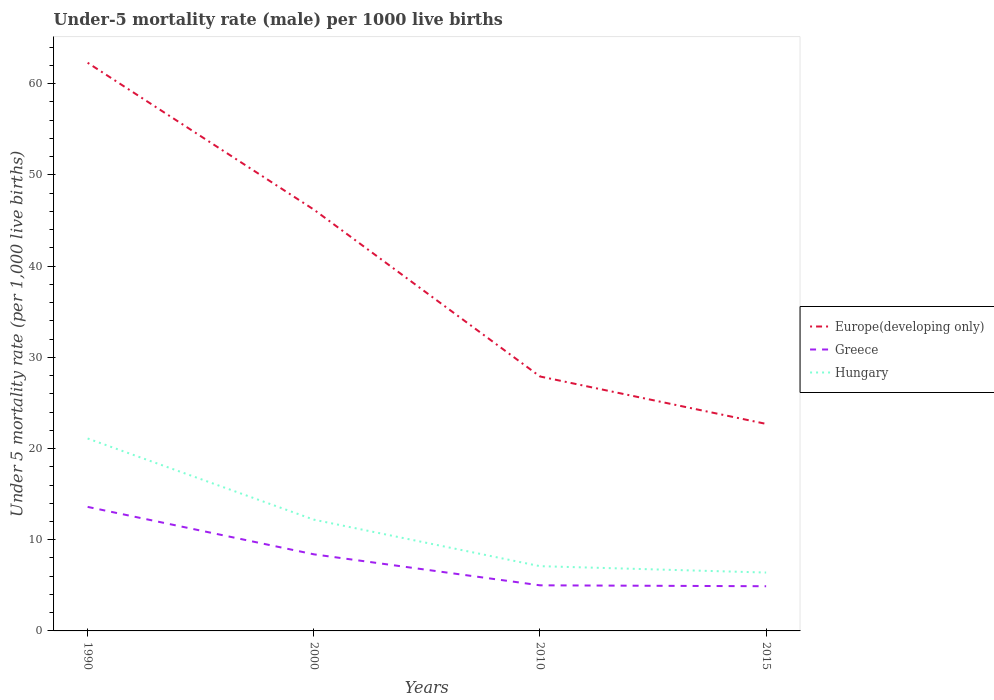Does the line corresponding to Europe(developing only) intersect with the line corresponding to Hungary?
Your answer should be very brief. No. Is the number of lines equal to the number of legend labels?
Offer a very short reply. Yes. Across all years, what is the maximum under-five mortality rate in Europe(developing only)?
Your response must be concise. 22.7. In which year was the under-five mortality rate in Europe(developing only) maximum?
Your answer should be compact. 2015. What is the total under-five mortality rate in Europe(developing only) in the graph?
Make the answer very short. 39.6. What is the difference between the highest and the second highest under-five mortality rate in Hungary?
Provide a succinct answer. 14.7. What is the difference between two consecutive major ticks on the Y-axis?
Offer a terse response. 10. Does the graph contain grids?
Offer a very short reply. No. Where does the legend appear in the graph?
Provide a succinct answer. Center right. How many legend labels are there?
Offer a terse response. 3. How are the legend labels stacked?
Offer a terse response. Vertical. What is the title of the graph?
Your response must be concise. Under-5 mortality rate (male) per 1000 live births. What is the label or title of the Y-axis?
Offer a very short reply. Under 5 mortality rate (per 1,0 live births). What is the Under 5 mortality rate (per 1,000 live births) of Europe(developing only) in 1990?
Ensure brevity in your answer.  62.3. What is the Under 5 mortality rate (per 1,000 live births) of Hungary in 1990?
Provide a succinct answer. 21.1. What is the Under 5 mortality rate (per 1,000 live births) in Europe(developing only) in 2000?
Offer a very short reply. 46.2. What is the Under 5 mortality rate (per 1,000 live births) in Europe(developing only) in 2010?
Offer a very short reply. 27.9. What is the Under 5 mortality rate (per 1,000 live births) of Europe(developing only) in 2015?
Your answer should be very brief. 22.7. What is the Under 5 mortality rate (per 1,000 live births) in Greece in 2015?
Provide a short and direct response. 4.9. Across all years, what is the maximum Under 5 mortality rate (per 1,000 live births) in Europe(developing only)?
Provide a succinct answer. 62.3. Across all years, what is the maximum Under 5 mortality rate (per 1,000 live births) of Hungary?
Provide a succinct answer. 21.1. Across all years, what is the minimum Under 5 mortality rate (per 1,000 live births) in Europe(developing only)?
Offer a terse response. 22.7. What is the total Under 5 mortality rate (per 1,000 live births) in Europe(developing only) in the graph?
Provide a succinct answer. 159.1. What is the total Under 5 mortality rate (per 1,000 live births) of Greece in the graph?
Offer a terse response. 31.9. What is the total Under 5 mortality rate (per 1,000 live births) in Hungary in the graph?
Keep it short and to the point. 46.8. What is the difference between the Under 5 mortality rate (per 1,000 live births) in Europe(developing only) in 1990 and that in 2000?
Ensure brevity in your answer.  16.1. What is the difference between the Under 5 mortality rate (per 1,000 live births) of Greece in 1990 and that in 2000?
Offer a very short reply. 5.2. What is the difference between the Under 5 mortality rate (per 1,000 live births) in Europe(developing only) in 1990 and that in 2010?
Provide a short and direct response. 34.4. What is the difference between the Under 5 mortality rate (per 1,000 live births) in Europe(developing only) in 1990 and that in 2015?
Offer a very short reply. 39.6. What is the difference between the Under 5 mortality rate (per 1,000 live births) of Greece in 1990 and that in 2015?
Your response must be concise. 8.7. What is the difference between the Under 5 mortality rate (per 1,000 live births) in Greece in 2000 and that in 2010?
Offer a terse response. 3.4. What is the difference between the Under 5 mortality rate (per 1,000 live births) in Greece in 2000 and that in 2015?
Offer a very short reply. 3.5. What is the difference between the Under 5 mortality rate (per 1,000 live births) in Europe(developing only) in 1990 and the Under 5 mortality rate (per 1,000 live births) in Greece in 2000?
Offer a terse response. 53.9. What is the difference between the Under 5 mortality rate (per 1,000 live births) in Europe(developing only) in 1990 and the Under 5 mortality rate (per 1,000 live births) in Hungary in 2000?
Give a very brief answer. 50.1. What is the difference between the Under 5 mortality rate (per 1,000 live births) in Greece in 1990 and the Under 5 mortality rate (per 1,000 live births) in Hungary in 2000?
Provide a succinct answer. 1.4. What is the difference between the Under 5 mortality rate (per 1,000 live births) of Europe(developing only) in 1990 and the Under 5 mortality rate (per 1,000 live births) of Greece in 2010?
Your response must be concise. 57.3. What is the difference between the Under 5 mortality rate (per 1,000 live births) in Europe(developing only) in 1990 and the Under 5 mortality rate (per 1,000 live births) in Hungary in 2010?
Your response must be concise. 55.2. What is the difference between the Under 5 mortality rate (per 1,000 live births) in Greece in 1990 and the Under 5 mortality rate (per 1,000 live births) in Hungary in 2010?
Your answer should be compact. 6.5. What is the difference between the Under 5 mortality rate (per 1,000 live births) of Europe(developing only) in 1990 and the Under 5 mortality rate (per 1,000 live births) of Greece in 2015?
Give a very brief answer. 57.4. What is the difference between the Under 5 mortality rate (per 1,000 live births) of Europe(developing only) in 1990 and the Under 5 mortality rate (per 1,000 live births) of Hungary in 2015?
Ensure brevity in your answer.  55.9. What is the difference between the Under 5 mortality rate (per 1,000 live births) in Europe(developing only) in 2000 and the Under 5 mortality rate (per 1,000 live births) in Greece in 2010?
Offer a very short reply. 41.2. What is the difference between the Under 5 mortality rate (per 1,000 live births) of Europe(developing only) in 2000 and the Under 5 mortality rate (per 1,000 live births) of Hungary in 2010?
Offer a terse response. 39.1. What is the difference between the Under 5 mortality rate (per 1,000 live births) of Greece in 2000 and the Under 5 mortality rate (per 1,000 live births) of Hungary in 2010?
Keep it short and to the point. 1.3. What is the difference between the Under 5 mortality rate (per 1,000 live births) of Europe(developing only) in 2000 and the Under 5 mortality rate (per 1,000 live births) of Greece in 2015?
Your answer should be very brief. 41.3. What is the difference between the Under 5 mortality rate (per 1,000 live births) of Europe(developing only) in 2000 and the Under 5 mortality rate (per 1,000 live births) of Hungary in 2015?
Your response must be concise. 39.8. What is the difference between the Under 5 mortality rate (per 1,000 live births) of Europe(developing only) in 2010 and the Under 5 mortality rate (per 1,000 live births) of Greece in 2015?
Ensure brevity in your answer.  23. What is the difference between the Under 5 mortality rate (per 1,000 live births) of Greece in 2010 and the Under 5 mortality rate (per 1,000 live births) of Hungary in 2015?
Provide a short and direct response. -1.4. What is the average Under 5 mortality rate (per 1,000 live births) in Europe(developing only) per year?
Your response must be concise. 39.77. What is the average Under 5 mortality rate (per 1,000 live births) in Greece per year?
Provide a short and direct response. 7.97. What is the average Under 5 mortality rate (per 1,000 live births) in Hungary per year?
Your answer should be very brief. 11.7. In the year 1990, what is the difference between the Under 5 mortality rate (per 1,000 live births) of Europe(developing only) and Under 5 mortality rate (per 1,000 live births) of Greece?
Ensure brevity in your answer.  48.7. In the year 1990, what is the difference between the Under 5 mortality rate (per 1,000 live births) of Europe(developing only) and Under 5 mortality rate (per 1,000 live births) of Hungary?
Keep it short and to the point. 41.2. In the year 2000, what is the difference between the Under 5 mortality rate (per 1,000 live births) in Europe(developing only) and Under 5 mortality rate (per 1,000 live births) in Greece?
Your answer should be very brief. 37.8. In the year 2010, what is the difference between the Under 5 mortality rate (per 1,000 live births) in Europe(developing only) and Under 5 mortality rate (per 1,000 live births) in Greece?
Provide a short and direct response. 22.9. In the year 2010, what is the difference between the Under 5 mortality rate (per 1,000 live births) of Europe(developing only) and Under 5 mortality rate (per 1,000 live births) of Hungary?
Ensure brevity in your answer.  20.8. In the year 2015, what is the difference between the Under 5 mortality rate (per 1,000 live births) in Europe(developing only) and Under 5 mortality rate (per 1,000 live births) in Greece?
Your answer should be compact. 17.8. In the year 2015, what is the difference between the Under 5 mortality rate (per 1,000 live births) of Europe(developing only) and Under 5 mortality rate (per 1,000 live births) of Hungary?
Make the answer very short. 16.3. What is the ratio of the Under 5 mortality rate (per 1,000 live births) in Europe(developing only) in 1990 to that in 2000?
Ensure brevity in your answer.  1.35. What is the ratio of the Under 5 mortality rate (per 1,000 live births) of Greece in 1990 to that in 2000?
Your answer should be compact. 1.62. What is the ratio of the Under 5 mortality rate (per 1,000 live births) of Hungary in 1990 to that in 2000?
Make the answer very short. 1.73. What is the ratio of the Under 5 mortality rate (per 1,000 live births) in Europe(developing only) in 1990 to that in 2010?
Keep it short and to the point. 2.23. What is the ratio of the Under 5 mortality rate (per 1,000 live births) in Greece in 1990 to that in 2010?
Your answer should be very brief. 2.72. What is the ratio of the Under 5 mortality rate (per 1,000 live births) of Hungary in 1990 to that in 2010?
Give a very brief answer. 2.97. What is the ratio of the Under 5 mortality rate (per 1,000 live births) in Europe(developing only) in 1990 to that in 2015?
Offer a terse response. 2.74. What is the ratio of the Under 5 mortality rate (per 1,000 live births) in Greece in 1990 to that in 2015?
Your answer should be compact. 2.78. What is the ratio of the Under 5 mortality rate (per 1,000 live births) in Hungary in 1990 to that in 2015?
Provide a succinct answer. 3.3. What is the ratio of the Under 5 mortality rate (per 1,000 live births) of Europe(developing only) in 2000 to that in 2010?
Make the answer very short. 1.66. What is the ratio of the Under 5 mortality rate (per 1,000 live births) in Greece in 2000 to that in 2010?
Give a very brief answer. 1.68. What is the ratio of the Under 5 mortality rate (per 1,000 live births) of Hungary in 2000 to that in 2010?
Keep it short and to the point. 1.72. What is the ratio of the Under 5 mortality rate (per 1,000 live births) in Europe(developing only) in 2000 to that in 2015?
Keep it short and to the point. 2.04. What is the ratio of the Under 5 mortality rate (per 1,000 live births) of Greece in 2000 to that in 2015?
Provide a succinct answer. 1.71. What is the ratio of the Under 5 mortality rate (per 1,000 live births) of Hungary in 2000 to that in 2015?
Give a very brief answer. 1.91. What is the ratio of the Under 5 mortality rate (per 1,000 live births) of Europe(developing only) in 2010 to that in 2015?
Keep it short and to the point. 1.23. What is the ratio of the Under 5 mortality rate (per 1,000 live births) in Greece in 2010 to that in 2015?
Your response must be concise. 1.02. What is the ratio of the Under 5 mortality rate (per 1,000 live births) in Hungary in 2010 to that in 2015?
Your response must be concise. 1.11. What is the difference between the highest and the second highest Under 5 mortality rate (per 1,000 live births) in Hungary?
Offer a very short reply. 8.9. What is the difference between the highest and the lowest Under 5 mortality rate (per 1,000 live births) of Europe(developing only)?
Provide a short and direct response. 39.6. What is the difference between the highest and the lowest Under 5 mortality rate (per 1,000 live births) in Greece?
Keep it short and to the point. 8.7. 